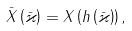Convert formula to latex. <formula><loc_0><loc_0><loc_500><loc_500>\bar { X } \left ( \bar { \varkappa } \right ) = X \left ( h \left ( \bar { \varkappa } \right ) \right ) ,</formula> 